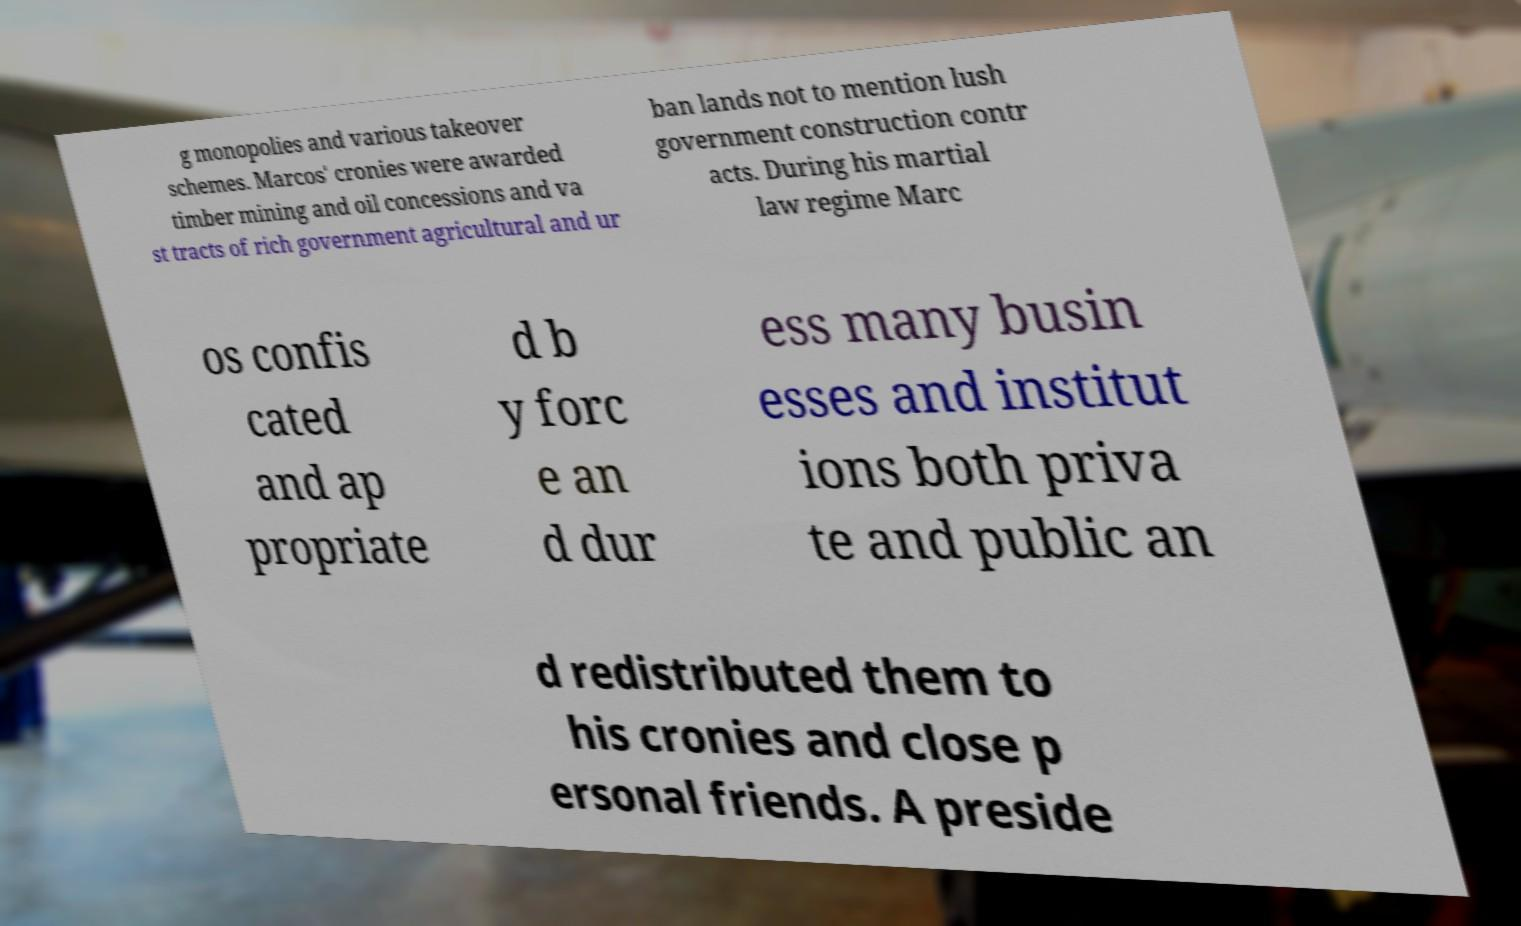Please read and relay the text visible in this image. What does it say? g monopolies and various takeover schemes. Marcos' cronies were awarded timber mining and oil concessions and va st tracts of rich government agricultural and ur ban lands not to mention lush government construction contr acts. During his martial law regime Marc os confis cated and ap propriate d b y forc e an d dur ess many busin esses and institut ions both priva te and public an d redistributed them to his cronies and close p ersonal friends. A preside 